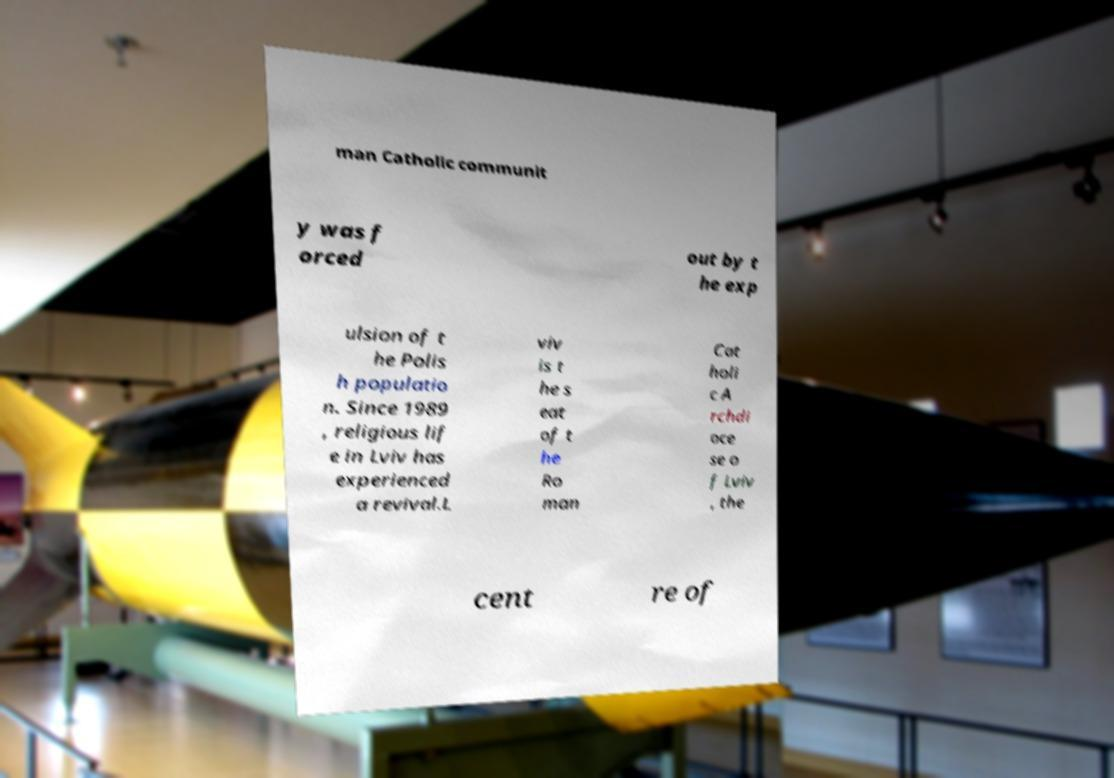What messages or text are displayed in this image? I need them in a readable, typed format. man Catholic communit y was f orced out by t he exp ulsion of t he Polis h populatio n. Since 1989 , religious lif e in Lviv has experienced a revival.L viv is t he s eat of t he Ro man Cat holi c A rchdi oce se o f Lviv , the cent re of 